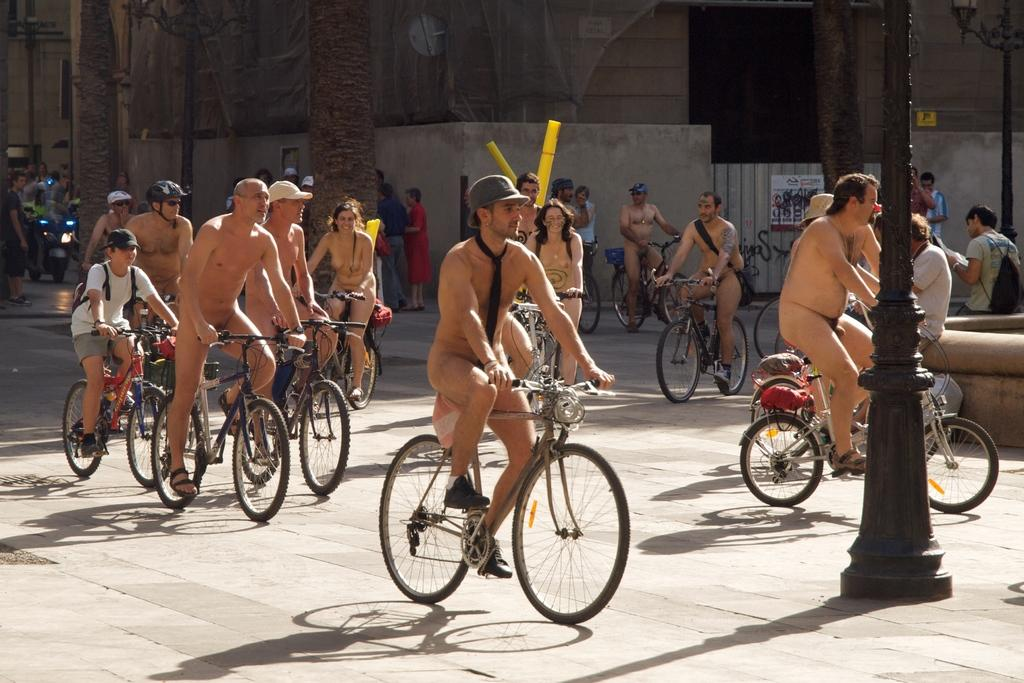What are the people in the image doing? The people in the image are riding bicycles. What is notable about the people's attire in the image? The people are not wearing clothes. What can be seen in the background of the image? There is a wall and a pole in the background of the image. Are there any other bicycles visible in the image? Yes, there is a bike in the background of the image. What type of steel is used to construct the chairs in the image? There are no chairs present in the image, so it is not possible to determine the type of steel used in their construction. 